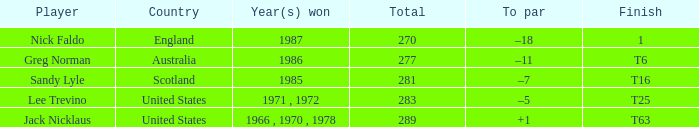What player has 1 as the place? Nick Faldo. 